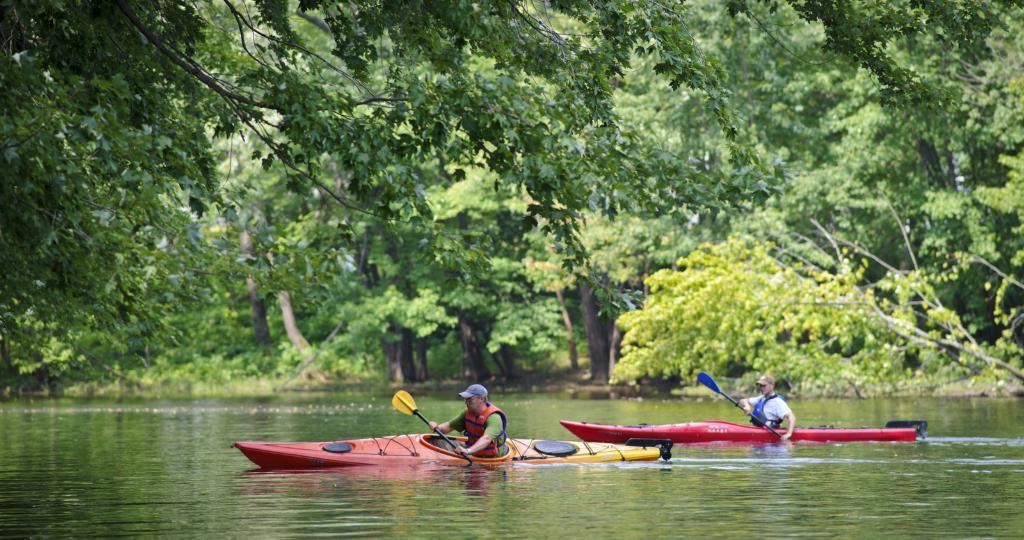How many people are in the image? There are two people in the image. What are the people doing in the image? The people are sitting on boats and holding paddles. Where are the boats located in the image? The boats are on the water. What can be seen in the background of the image? There are trees visible in the background. What type of pizzas are being served at the church in the image? There is no church or pizzas present in the image; it features two people sitting on boats on the water. 